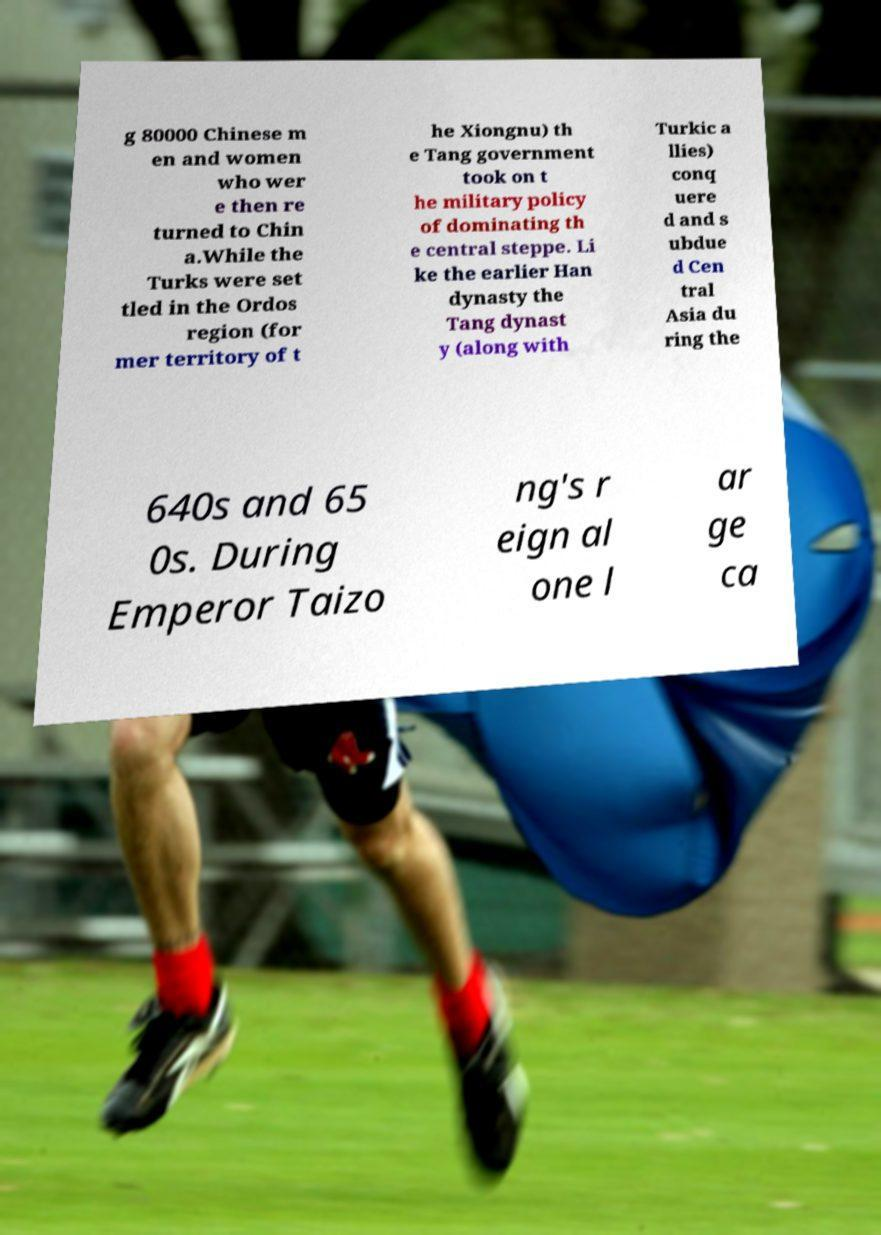Could you assist in decoding the text presented in this image and type it out clearly? g 80000 Chinese m en and women who wer e then re turned to Chin a.While the Turks were set tled in the Ordos region (for mer territory of t he Xiongnu) th e Tang government took on t he military policy of dominating th e central steppe. Li ke the earlier Han dynasty the Tang dynast y (along with Turkic a llies) conq uere d and s ubdue d Cen tral Asia du ring the 640s and 65 0s. During Emperor Taizo ng's r eign al one l ar ge ca 